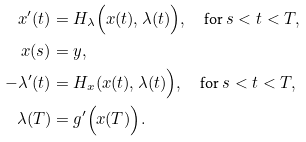<formula> <loc_0><loc_0><loc_500><loc_500>x ^ { \prime } ( t ) & = H _ { \lambda } \Big ( x ( t ) , \lambda ( t ) \Big ) , \quad \text {for } s < t < T , \\ x ( s ) & = y , \\ - \lambda ^ { \prime } ( t ) & = H _ { x } ( x ( t ) , \lambda ( t ) \Big ) , \quad \text {for } s < t < T , \\ \lambda ( T ) & = g ^ { \prime } \Big ( x ( T ) \Big ) .</formula> 